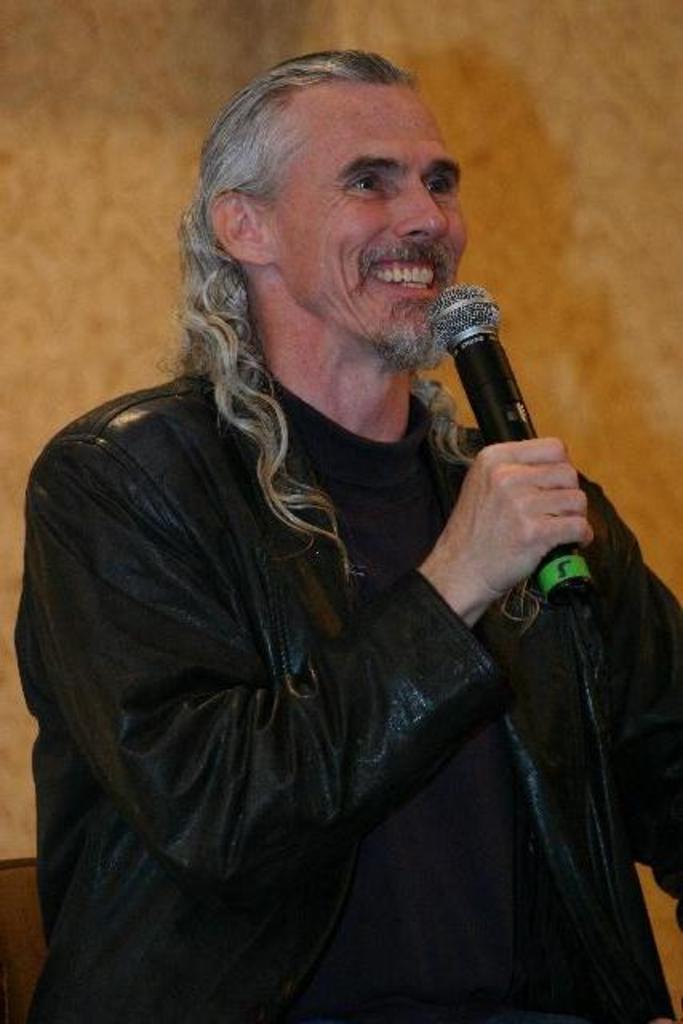Describe this image in one or two sentences. In this image, we can see a man wearing a black color dress and holding a microphone in his hand. In the background, we can see orange color. 